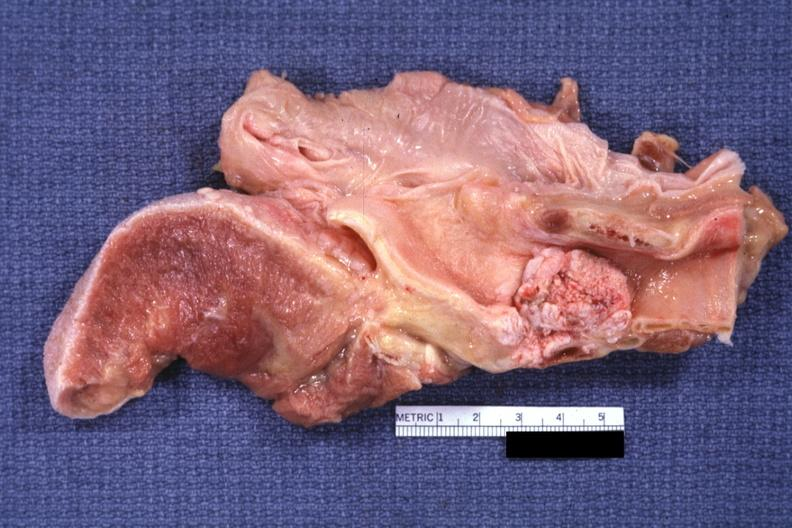what is present?
Answer the question using a single word or phrase. Larynx 